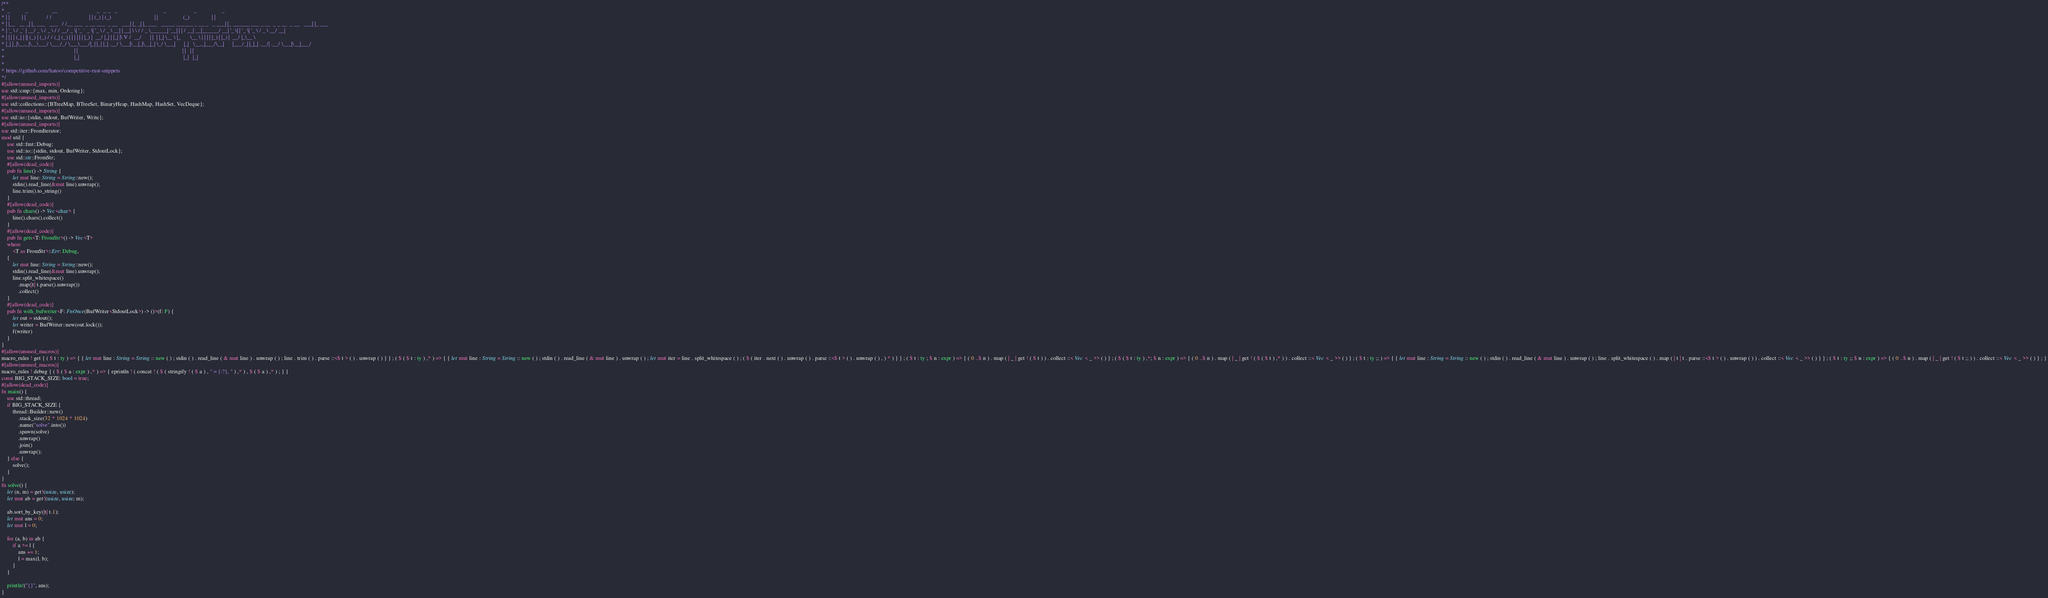Convert code to text. <code><loc_0><loc_0><loc_500><loc_500><_Rust_>/**
*  _           _                 __                            _   _ _   _                                 _                    _                  _
* | |         | |               / /                           | | (_) | (_)                               | |                  (_)                | |
* | |__   __ _| |_ ___   ___   / /__ ___  _ __ ___  _ __   ___| |_ _| |_ ___   _____ ______ _ __ _   _ ___| |_ ______ ___ _ __  _ _ __  _ __   ___| |_ ___
* | '_ \ / _` | __/ _ \ / _ \ / / __/ _ \| '_ ` _ \| '_ \ / _ \ __| | __| \ \ / / _ \______| '__| | | / __| __|______/ __| '_ \| | '_ \| '_ \ / _ \ __/ __|
* | | | | (_| | || (_) | (_) / / (_| (_) | | | | | | |_) |  __/ |_| | |_| |\ V /  __/      | |  | |_| \__ \ |_       \__ \ | | | | |_) | |_) |  __/ |_\__ \
* |_| |_|\__,_|\__\___/ \___/_/ \___\___/|_| |_| |_| .__/ \___|\__|_|\__|_| \_/ \___|      |_|   \__,_|___/\__|      |___/_| |_|_| .__/| .__/ \___|\__|___/
*                                                  | |                                                                           | |   | |
*                                                  |_|                                                                           |_|   |_|
*
* https://github.com/hatoo/competitive-rust-snippets
*/
#[allow(unused_imports)]
use std::cmp::{max, min, Ordering};
#[allow(unused_imports)]
use std::collections::{BTreeMap, BTreeSet, BinaryHeap, HashMap, HashSet, VecDeque};
#[allow(unused_imports)]
use std::io::{stdin, stdout, BufWriter, Write};
#[allow(unused_imports)]
use std::iter::FromIterator;
mod util {
    use std::fmt::Debug;
    use std::io::{stdin, stdout, BufWriter, StdoutLock};
    use std::str::FromStr;
    #[allow(dead_code)]
    pub fn line() -> String {
        let mut line: String = String::new();
        stdin().read_line(&mut line).unwrap();
        line.trim().to_string()
    }
    #[allow(dead_code)]
    pub fn chars() -> Vec<char> {
        line().chars().collect()
    }
    #[allow(dead_code)]
    pub fn gets<T: FromStr>() -> Vec<T>
    where
        <T as FromStr>::Err: Debug,
    {
        let mut line: String = String::new();
        stdin().read_line(&mut line).unwrap();
        line.split_whitespace()
            .map(|t| t.parse().unwrap())
            .collect()
    }
    #[allow(dead_code)]
    pub fn with_bufwriter<F: FnOnce(BufWriter<StdoutLock>) -> ()>(f: F) {
        let out = stdout();
        let writer = BufWriter::new(out.lock());
        f(writer)
    }
}
#[allow(unused_macros)]
macro_rules ! get { ( $ t : ty ) => { { let mut line : String = String :: new ( ) ; stdin ( ) . read_line ( & mut line ) . unwrap ( ) ; line . trim ( ) . parse ::<$ t > ( ) . unwrap ( ) } } ; ( $ ( $ t : ty ) ,* ) => { { let mut line : String = String :: new ( ) ; stdin ( ) . read_line ( & mut line ) . unwrap ( ) ; let mut iter = line . split_whitespace ( ) ; ( $ ( iter . next ( ) . unwrap ( ) . parse ::<$ t > ( ) . unwrap ( ) , ) * ) } } ; ( $ t : ty ; $ n : expr ) => { ( 0 ..$ n ) . map ( | _ | get ! ( $ t ) ) . collect ::< Vec < _ >> ( ) } ; ( $ ( $ t : ty ) ,*; $ n : expr ) => { ( 0 ..$ n ) . map ( | _ | get ! ( $ ( $ t ) ,* ) ) . collect ::< Vec < _ >> ( ) } ; ( $ t : ty ;; ) => { { let mut line : String = String :: new ( ) ; stdin ( ) . read_line ( & mut line ) . unwrap ( ) ; line . split_whitespace ( ) . map ( | t | t . parse ::<$ t > ( ) . unwrap ( ) ) . collect ::< Vec < _ >> ( ) } } ; ( $ t : ty ;; $ n : expr ) => { ( 0 ..$ n ) . map ( | _ | get ! ( $ t ;; ) ) . collect ::< Vec < _ >> ( ) } ; }
#[allow(unused_macros)]
macro_rules ! debug { ( $ ( $ a : expr ) ,* ) => { eprintln ! ( concat ! ( $ ( stringify ! ( $ a ) , " = {:?}, " ) ,* ) , $ ( $ a ) ,* ) ; } }
const BIG_STACK_SIZE: bool = true;
#[allow(dead_code)]
fn main() {
    use std::thread;
    if BIG_STACK_SIZE {
        thread::Builder::new()
            .stack_size(32 * 1024 * 1024)
            .name("solve".into())
            .spawn(solve)
            .unwrap()
            .join()
            .unwrap();
    } else {
        solve();
    }
}
fn solve() {
    let (n, m) = get!(usize, usize);
    let mut ab = get!(usize, usize; m);

    ab.sort_by_key(|t| t.1);
    let mut ans = 0;
    let mut l = 0;

    for (a, b) in ab {
        if a >= l {
            ans += 1;
            l = max(l, b);
        }
    }

    println!("{}", ans);
}
</code> 